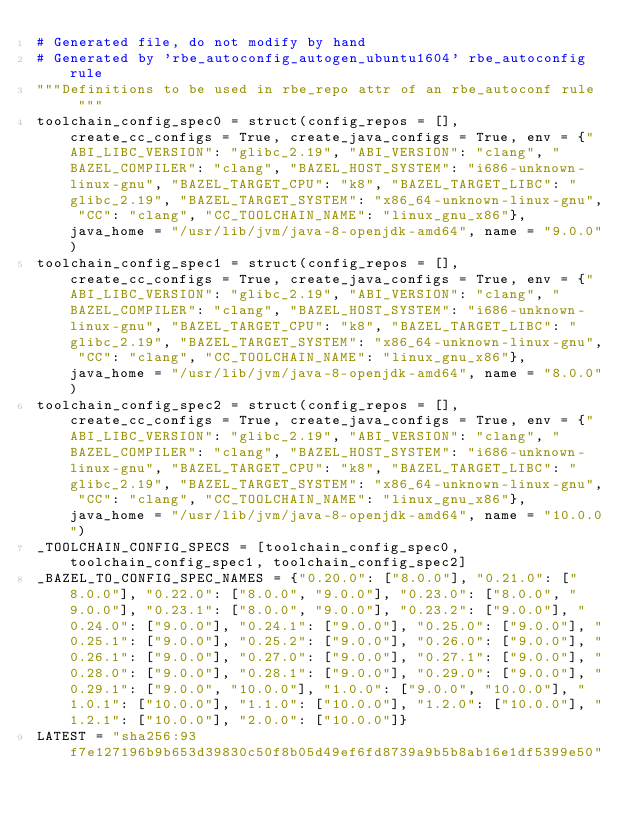Convert code to text. <code><loc_0><loc_0><loc_500><loc_500><_Python_># Generated file, do not modify by hand
# Generated by 'rbe_autoconfig_autogen_ubuntu1604' rbe_autoconfig rule
"""Definitions to be used in rbe_repo attr of an rbe_autoconf rule  """
toolchain_config_spec0 = struct(config_repos = [], create_cc_configs = True, create_java_configs = True, env = {"ABI_LIBC_VERSION": "glibc_2.19", "ABI_VERSION": "clang", "BAZEL_COMPILER": "clang", "BAZEL_HOST_SYSTEM": "i686-unknown-linux-gnu", "BAZEL_TARGET_CPU": "k8", "BAZEL_TARGET_LIBC": "glibc_2.19", "BAZEL_TARGET_SYSTEM": "x86_64-unknown-linux-gnu", "CC": "clang", "CC_TOOLCHAIN_NAME": "linux_gnu_x86"}, java_home = "/usr/lib/jvm/java-8-openjdk-amd64", name = "9.0.0")
toolchain_config_spec1 = struct(config_repos = [], create_cc_configs = True, create_java_configs = True, env = {"ABI_LIBC_VERSION": "glibc_2.19", "ABI_VERSION": "clang", "BAZEL_COMPILER": "clang", "BAZEL_HOST_SYSTEM": "i686-unknown-linux-gnu", "BAZEL_TARGET_CPU": "k8", "BAZEL_TARGET_LIBC": "glibc_2.19", "BAZEL_TARGET_SYSTEM": "x86_64-unknown-linux-gnu", "CC": "clang", "CC_TOOLCHAIN_NAME": "linux_gnu_x86"}, java_home = "/usr/lib/jvm/java-8-openjdk-amd64", name = "8.0.0")
toolchain_config_spec2 = struct(config_repos = [], create_cc_configs = True, create_java_configs = True, env = {"ABI_LIBC_VERSION": "glibc_2.19", "ABI_VERSION": "clang", "BAZEL_COMPILER": "clang", "BAZEL_HOST_SYSTEM": "i686-unknown-linux-gnu", "BAZEL_TARGET_CPU": "k8", "BAZEL_TARGET_LIBC": "glibc_2.19", "BAZEL_TARGET_SYSTEM": "x86_64-unknown-linux-gnu", "CC": "clang", "CC_TOOLCHAIN_NAME": "linux_gnu_x86"}, java_home = "/usr/lib/jvm/java-8-openjdk-amd64", name = "10.0.0")
_TOOLCHAIN_CONFIG_SPECS = [toolchain_config_spec0, toolchain_config_spec1, toolchain_config_spec2]
_BAZEL_TO_CONFIG_SPEC_NAMES = {"0.20.0": ["8.0.0"], "0.21.0": ["8.0.0"], "0.22.0": ["8.0.0", "9.0.0"], "0.23.0": ["8.0.0", "9.0.0"], "0.23.1": ["8.0.0", "9.0.0"], "0.23.2": ["9.0.0"], "0.24.0": ["9.0.0"], "0.24.1": ["9.0.0"], "0.25.0": ["9.0.0"], "0.25.1": ["9.0.0"], "0.25.2": ["9.0.0"], "0.26.0": ["9.0.0"], "0.26.1": ["9.0.0"], "0.27.0": ["9.0.0"], "0.27.1": ["9.0.0"], "0.28.0": ["9.0.0"], "0.28.1": ["9.0.0"], "0.29.0": ["9.0.0"], "0.29.1": ["9.0.0", "10.0.0"], "1.0.0": ["9.0.0", "10.0.0"], "1.0.1": ["10.0.0"], "1.1.0": ["10.0.0"], "1.2.0": ["10.0.0"], "1.2.1": ["10.0.0"], "2.0.0": ["10.0.0"]}
LATEST = "sha256:93f7e127196b9b653d39830c50f8b05d49ef6fd8739a9b5b8ab16e1df5399e50"</code> 